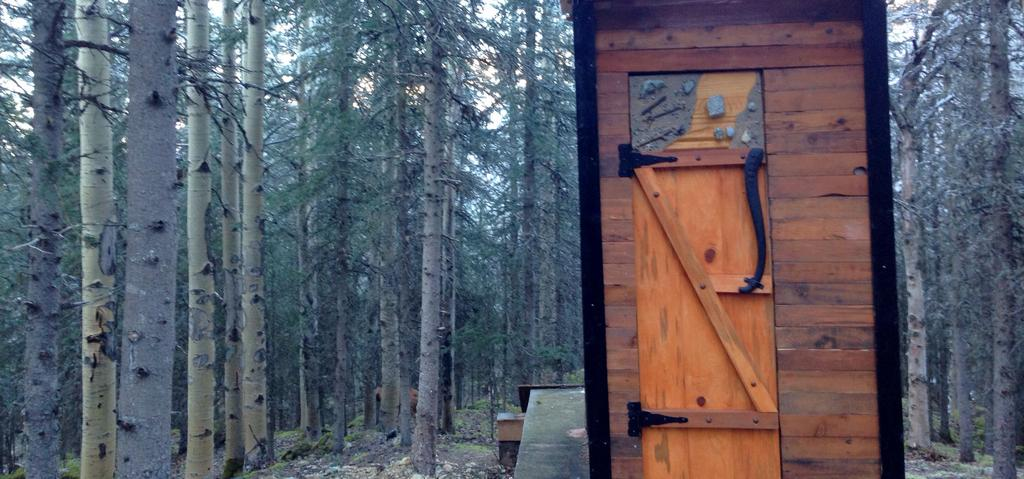What type of material is used for the wall in the image? The wall in the image is made of wood. What can be seen in the background of the image? Trees are visible in the image. Can you see a giraffe standing next to the wooden wall in the image? No, there is no giraffe present in the image. 